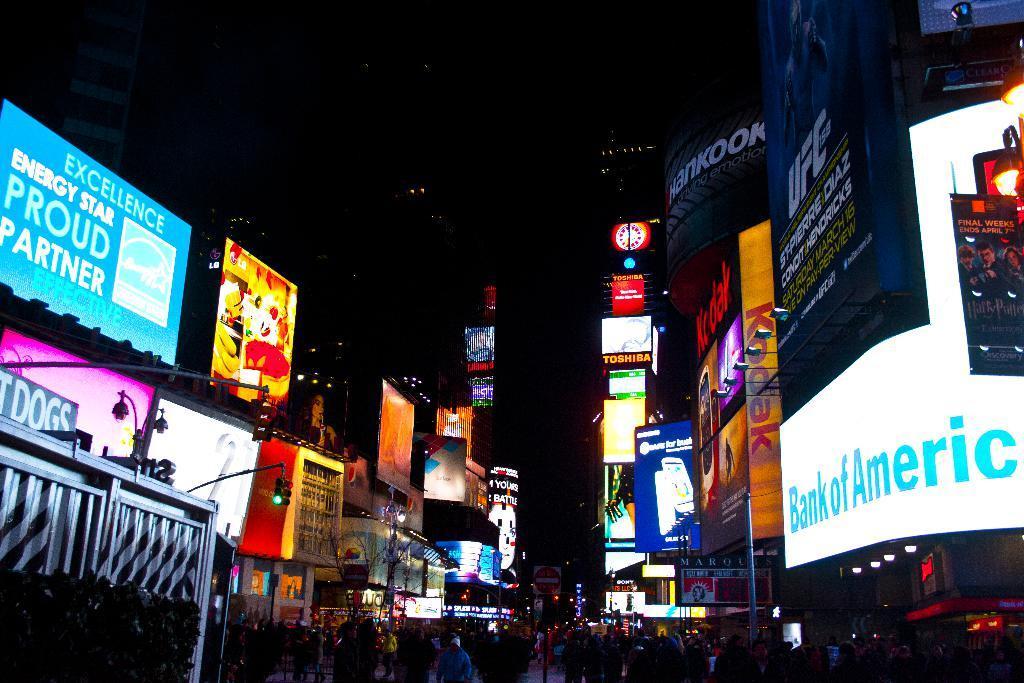Please provide a concise description of this image. This is the picture of a city. In this image there are buildings and there are boards on the buildings. At the top there is sky. At the bottom there are group of people on the road and there are poles on the footpath. 